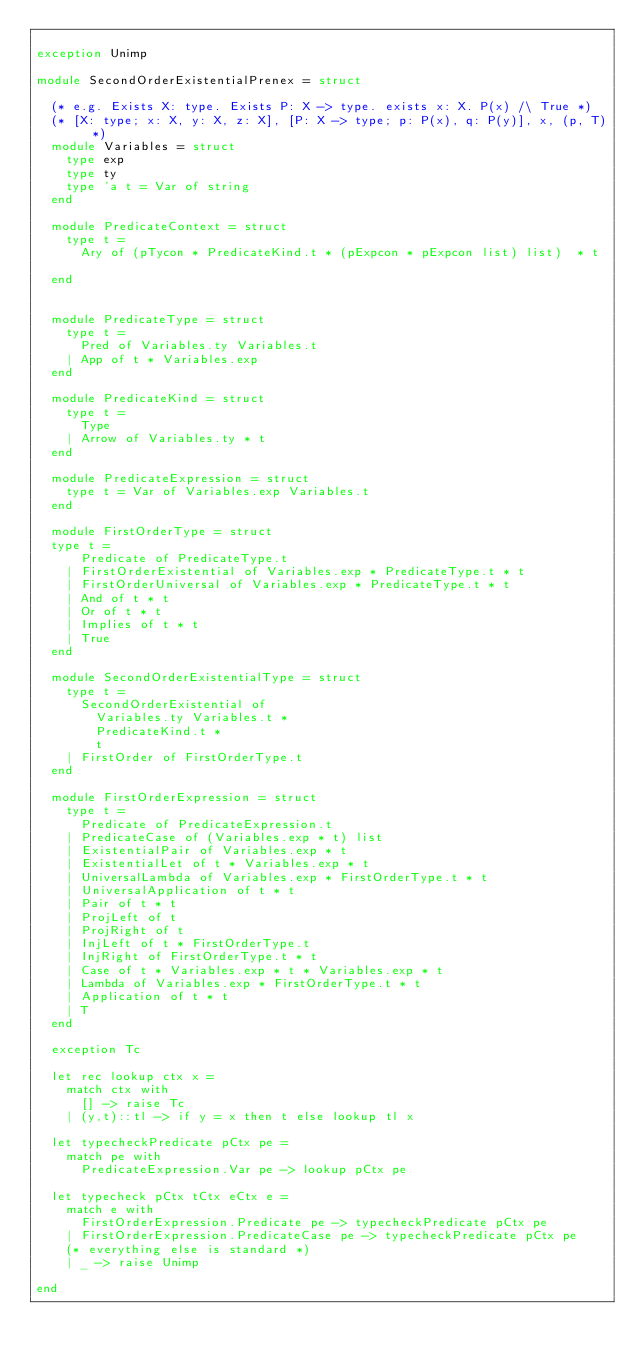<code> <loc_0><loc_0><loc_500><loc_500><_OCaml_>
exception Unimp

module SecondOrderExistentialPrenex = struct

  (* e.g. Exists X: type. Exists P: X -> type. exists x: X. P(x) /\ True *)
  (* [X: type; x: X, y: X, z: X], [P: X -> type; p: P(x), q: P(y)], x, (p, T) *)
  module Variables = struct
    type exp
    type ty
    type 'a t = Var of string
  end

  module PredicateContext = struct
    type t =
      Ary of (pTycon * PredicateKind.t * (pExpcon * pExpcon list) list)  * t
      
  end
 

  module PredicateType = struct
    type t =
      Pred of Variables.ty Variables.t
    | App of t * Variables.exp
  end

  module PredicateKind = struct
    type t =
      Type
    | Arrow of Variables.ty * t
  end

  module PredicateExpression = struct
    type t = Var of Variables.exp Variables.t
  end

  module FirstOrderType = struct
  type t =  
      Predicate of PredicateType.t
    | FirstOrderExistential of Variables.exp * PredicateType.t * t
    | FirstOrderUniversal of Variables.exp * PredicateType.t * t
    | And of t * t
    | Or of t * t
    | Implies of t * t
    | True
  end

  module SecondOrderExistentialType = struct
    type t =
      SecondOrderExistential of
        Variables.ty Variables.t *
        PredicateKind.t *
        t
    | FirstOrder of FirstOrderType.t
  end

  module FirstOrderExpression = struct
    type t = 
      Predicate of PredicateExpression.t 
    | PredicateCase of (Variables.exp * t) list
    | ExistentialPair of Variables.exp * t
    | ExistentialLet of t * Variables.exp * t
    | UniversalLambda of Variables.exp * FirstOrderType.t * t
    | UniversalApplication of t * t
    | Pair of t * t
    | ProjLeft of t
    | ProjRight of t
    | InjLeft of t * FirstOrderType.t
    | InjRight of FirstOrderType.t * t
    | Case of t * Variables.exp * t * Variables.exp * t
    | Lambda of Variables.exp * FirstOrderType.t * t
    | Application of t * t
    | T
  end

  exception Tc

  let rec lookup ctx x = 
    match ctx with 
      [] -> raise Tc
    | (y,t)::tl -> if y = x then t else lookup tl x

  let typecheckPredicate pCtx pe = 
    match pe with
      PredicateExpression.Var pe -> lookup pCtx pe

  let typecheck pCtx tCtx eCtx e =
    match e with
      FirstOrderExpression.Predicate pe -> typecheckPredicate pCtx pe
    | FirstOrderExpression.PredicateCase pe -> typecheckPredicate pCtx pe
    (* everything else is standard *)
    | _ -> raise Unimp  

end
</code> 